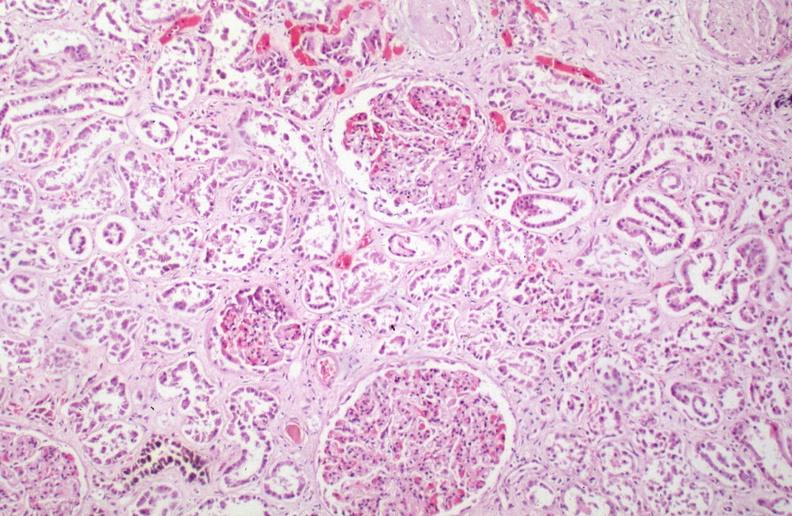what is hemosiderosis caused?
Answer the question using a single word or phrase. By numerous blood transfusions 